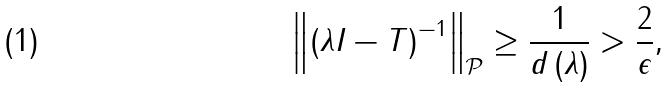<formula> <loc_0><loc_0><loc_500><loc_500>\left \| \left ( \lambda I - T \right ) ^ { - 1 } \right \| _ { \mathcal { P } } \geq \frac { 1 } { d \left ( \lambda \right ) } > \frac { 2 } { \epsilon } ,</formula> 